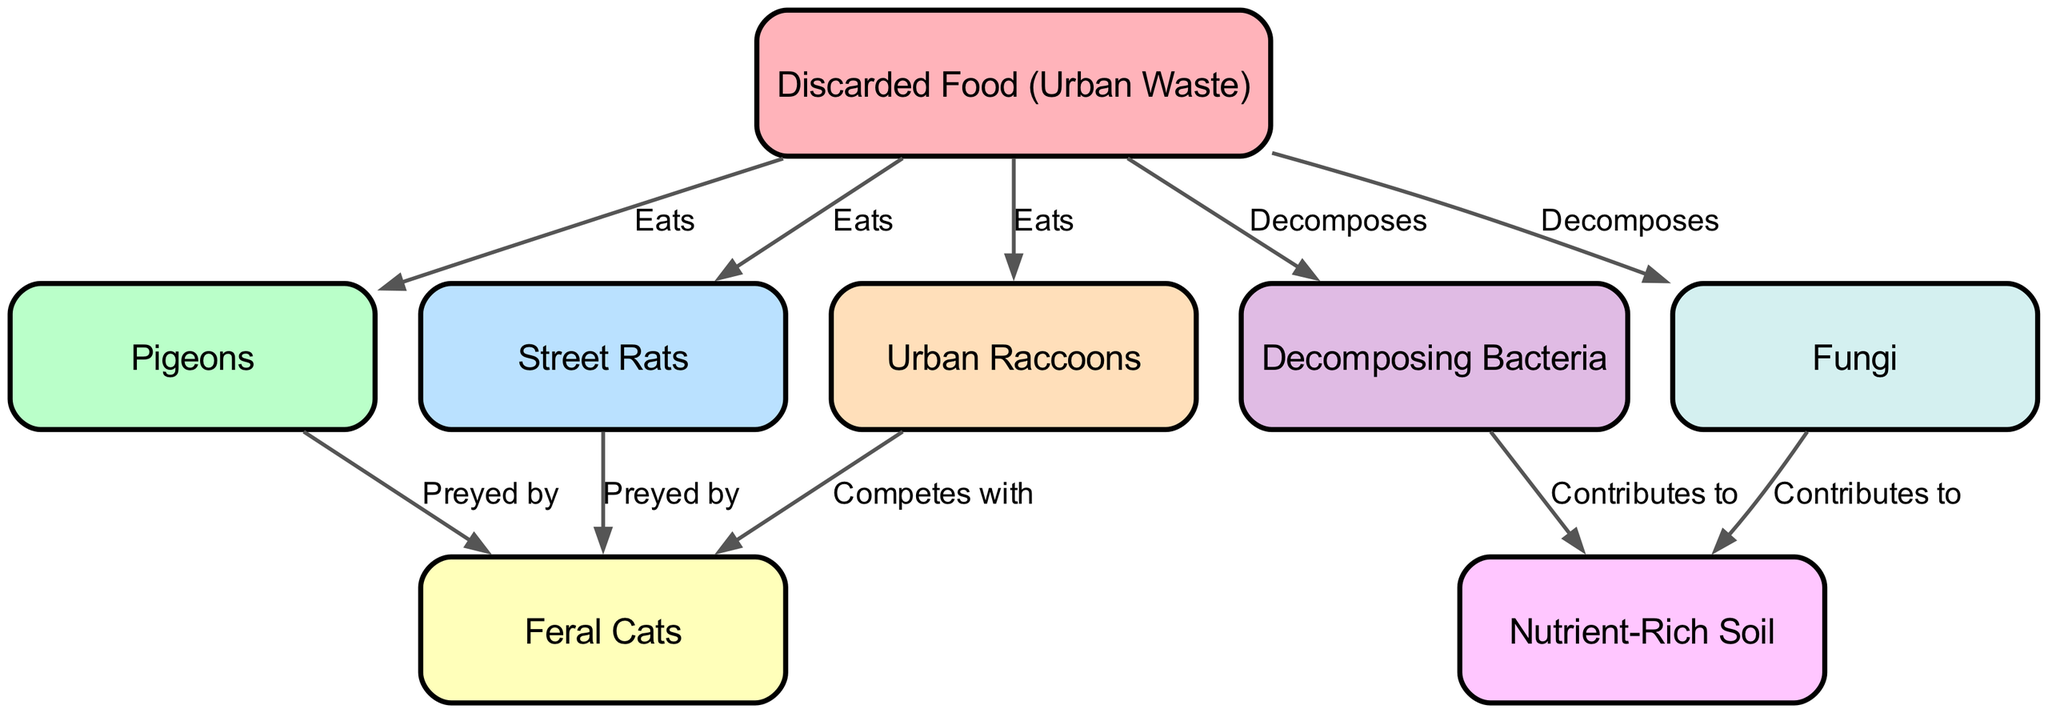What is the main source of food in this urban food chain? The main source of food is represented by the node labeled "Discarded Food (Urban Waste)," which is directly connected to the various scavengers identified in the diagram.
Answer: Discarded Food (Urban Waste) How many nodes are present in the diagram? By counting the nodes listed in the data, we can see there are a total of 8 unique nodes representing elements in the urban food chain.
Answer: 8 Which animals are directly preyed upon by feral cats? The feral cats are depicted as being preyed upon by both pigeons and street rats, as indicated by the directed edges leading to the feral cats node from these two nodes.
Answer: Pigeons and Street Rats What role do decomposing bacteria and fungi play in this food chain? Both decomposing bacteria and fungi are indicated to be important contributors to nutrient-rich soil, as shown by the arrows pointing from these decomposers to the node labeled "Nutrient-Rich Soil."
Answer: Contributes to Nutrient-Rich Soil Which organism competes with urban raccoons for food? Urban raccoons are shown to compete with feral cats, as indicated by the edge labeled "Competes with" connecting these two nodes.
Answer: Feral Cats How many scavengers are directly associated with discarded food? The diagrams indicate that there are four scavengers that eat discarded food: pigeons, street rats, urban raccoons, and feral cats. By counting these, we can confirm the number.
Answer: 4 What is the consequence of decomposing food waste in the urban environment? Decomposing food waste leads to the creation of nutrient-rich soil, as shown by the arrows leading from decomposing bacteria and fungi to this output node.
Answer: Nutrient-Rich Soil Which organisms are involved in the decomposition process? The organisms involved in decomposition within this food chain include decomposing bacteria and fungi, both of which are explicitly listed as nodes contributing to nutrient enrichment.
Answer: Decomposing Bacteria and Fungi 